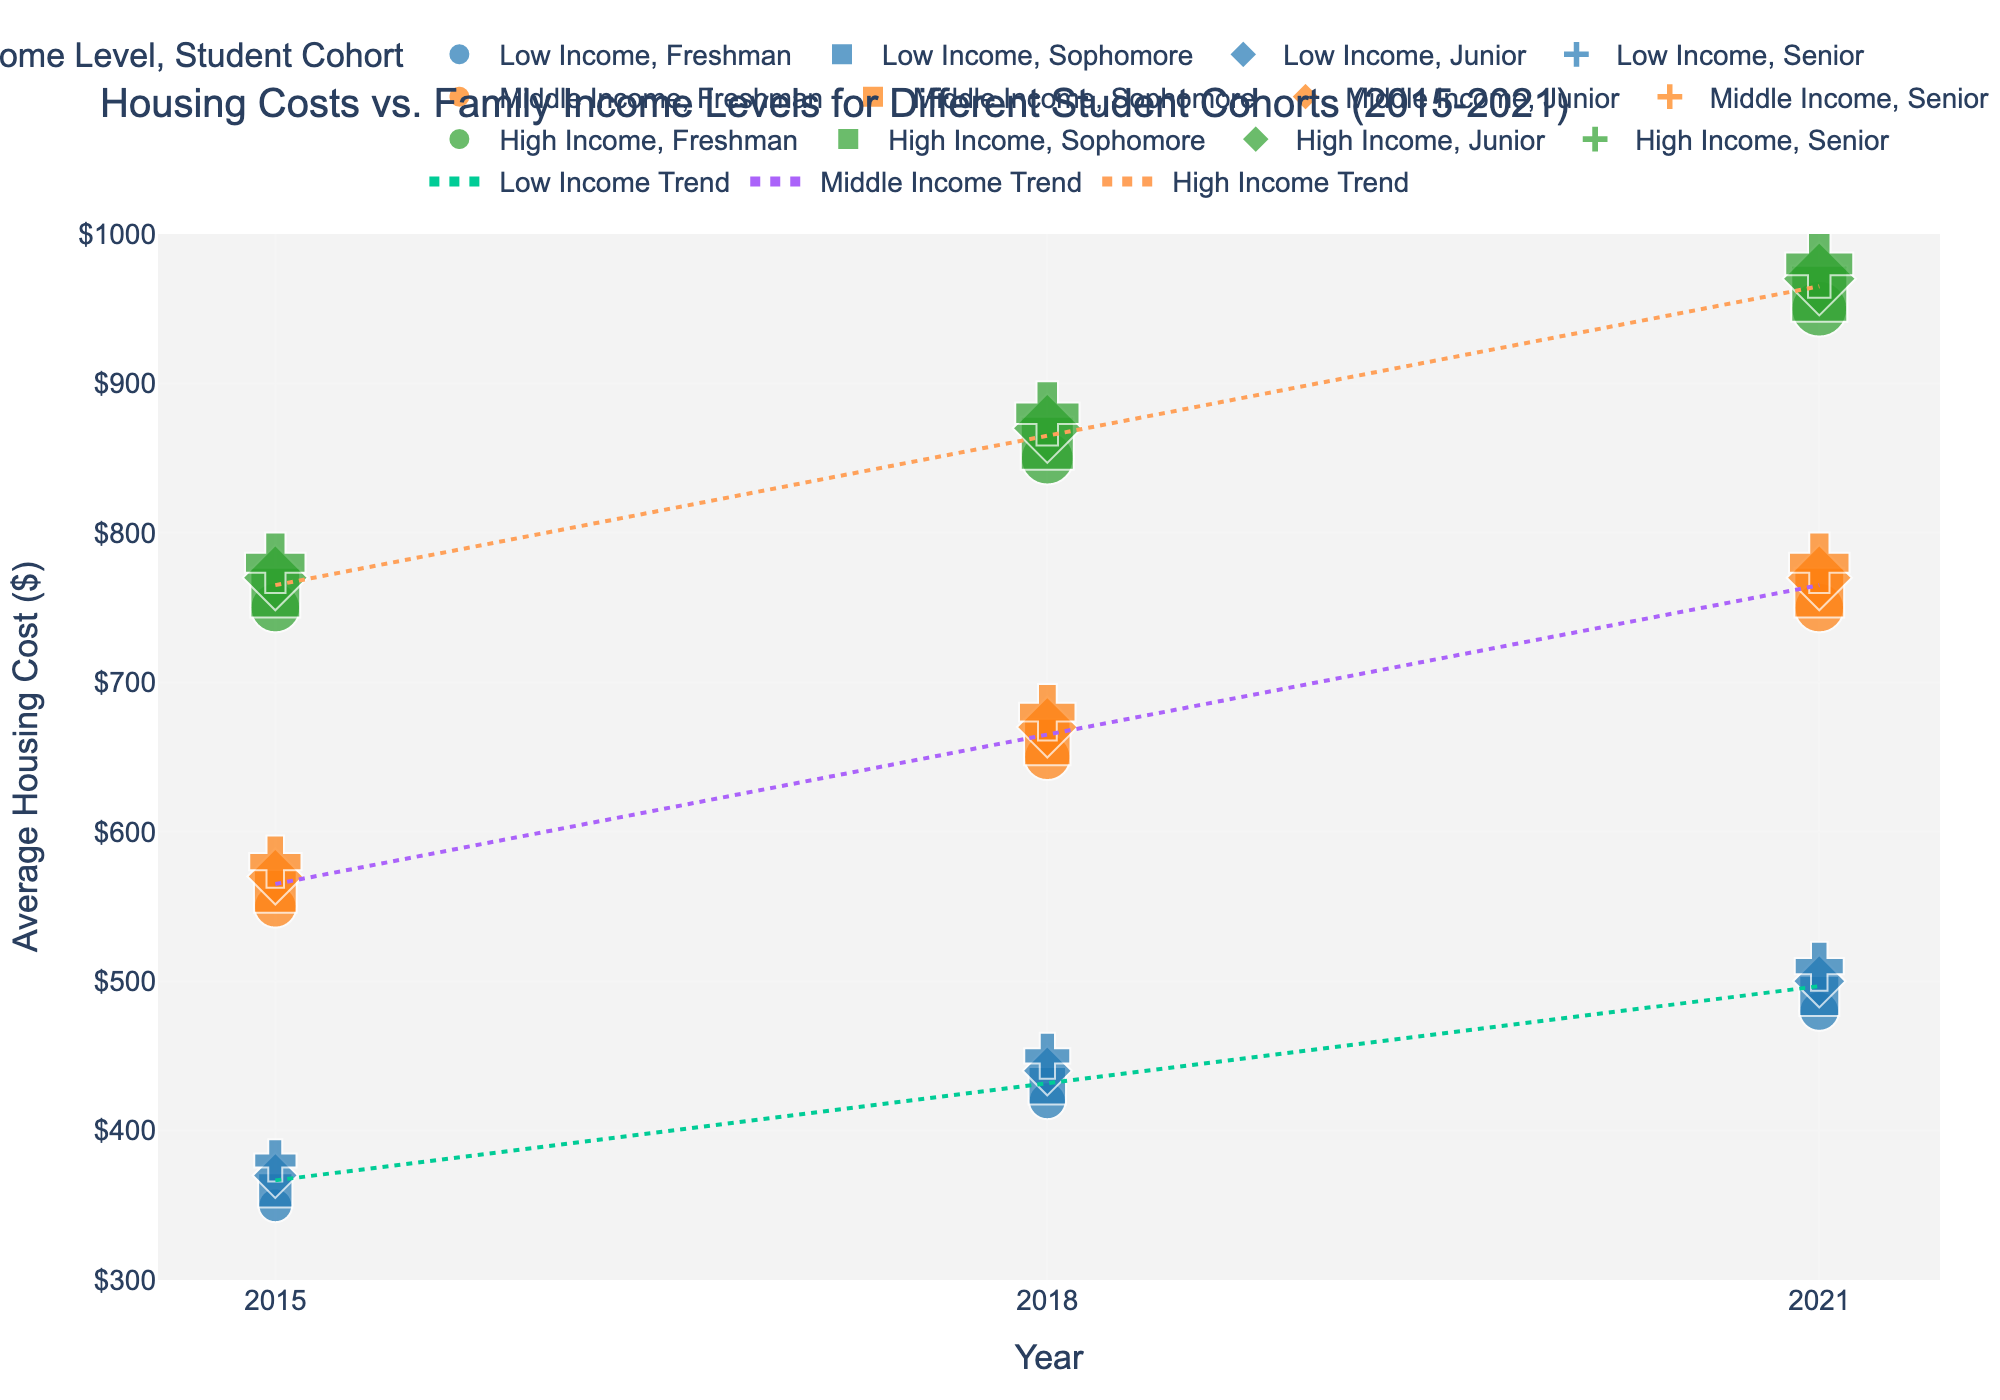What is the title of the figure? The title is located at the top of the figure and describes the overall content.
Answer: Housing Costs vs. Family Income Levels for Different Student Cohorts (2015-2021) Which income level has the highest average housing cost in 2021? In 2021, look for the comparison markers (dots) for each income level and assess which has the highest value along the y-axis.
Answer: High Income How do the average housing costs for freshmen compare between 2015 and 2021? Identify the markers for freshmen in both 2015 and 2021 and note their positions on the y-axis. The cost in 2015 is $350 for low income and $480 in 2021, etc. Compare both values.
Answer: Higher in 2021 Which student cohort shows the smallest increase in average housing cost from 2015 to 2021? Check the markers for each cohort in both years and calculate the increase for each, comparing the differences. For example, Freshman (Low Income) increased more compared to Junior (Low Income).
Answer: Senior Are there any trend lines that suggest a significant deviation in housing costs over the years for a specific income level? Observe the trend lines added to the plot for each income level and note any steep changes or deviations.
Answer: High Income Trend What is the average housing cost for middle-income sophomores in 2018? Find the specific marker for middle income and sophomore in 2018, as indicated in the hover data near the symbol.
Answer: $660 How do housing costs vary between low-income juniors and high-income juniors in 2015? Identify the respective markers for low-income and high-income juniors in 2015 and compare their positions on the y-axis.
Answer: $370 vs. $770 What pattern or trend can you observe for high-income family housing costs from 2015 to 2021? Follow the trend lines and markers for high-income families across the years and assess the direction and steepness of the trend.
Answer: Increasing trend By how much did the average housing cost for low-income seniors increase from 2015 to 2021? Find the markers for low-income seniors in 2015 and 2021. Compute the difference in their corresponding y-axis values ($510 - $380).
Answer: $130 